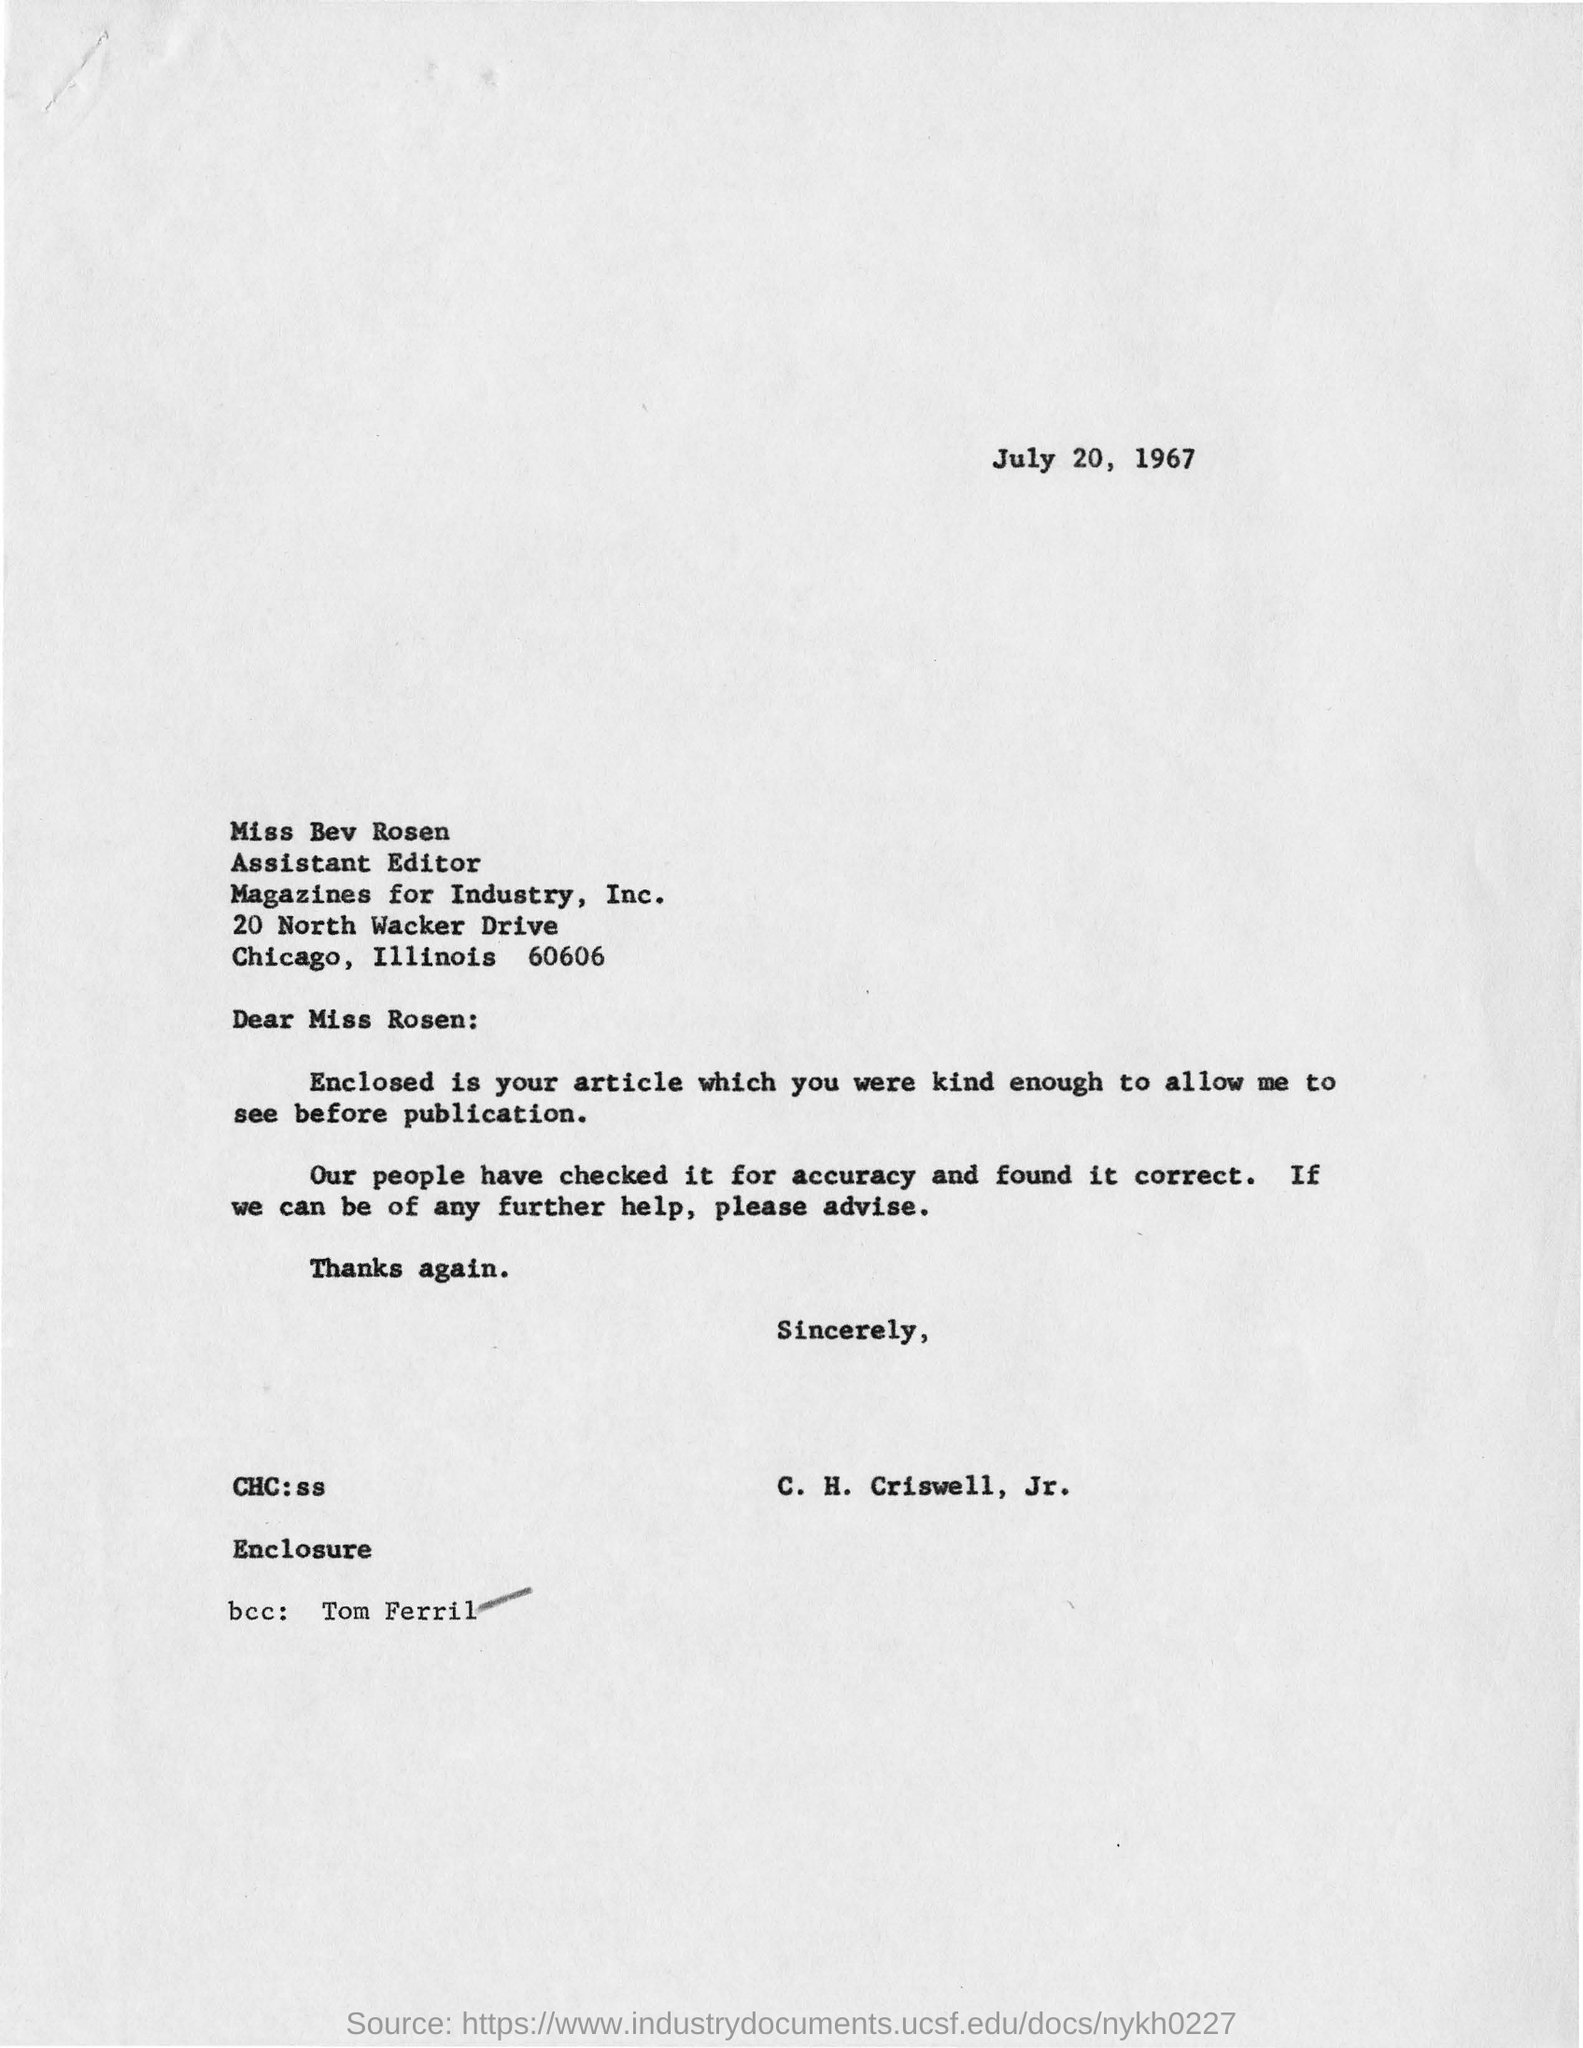Specify some key components in this picture. The letter was sent by C. H. Criswell, Jr. The subject of the sentence is "To whom is this letter addressed?", the verb is "is addressed", and the direct object is "Miss Bev Rosen". Therefore, the sentence is: "To whom is this letter addressed? It is addressed to Miss Bev Rosen. The date mentioned is July 20, 1967. The recipient of the email, whose name is Tom Ferril, is the BCC. 